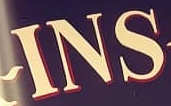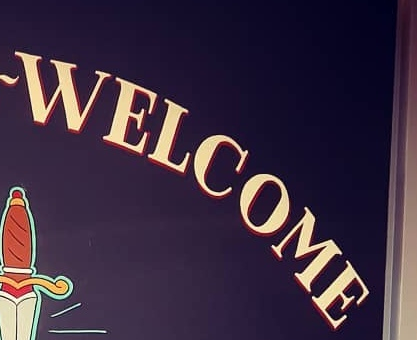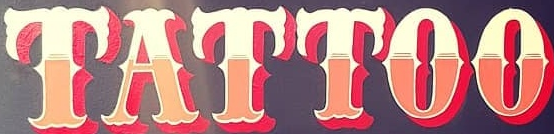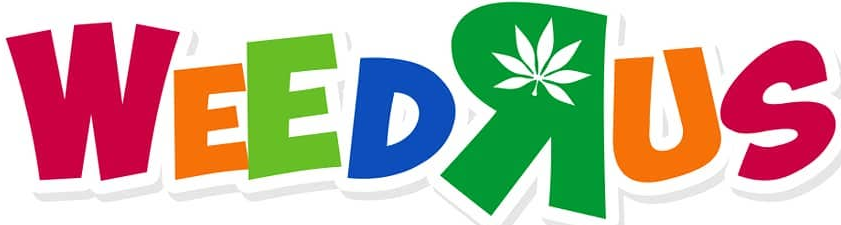Identify the words shown in these images in order, separated by a semicolon. INS; WELCOME; TATTOO; WEEDRUS 